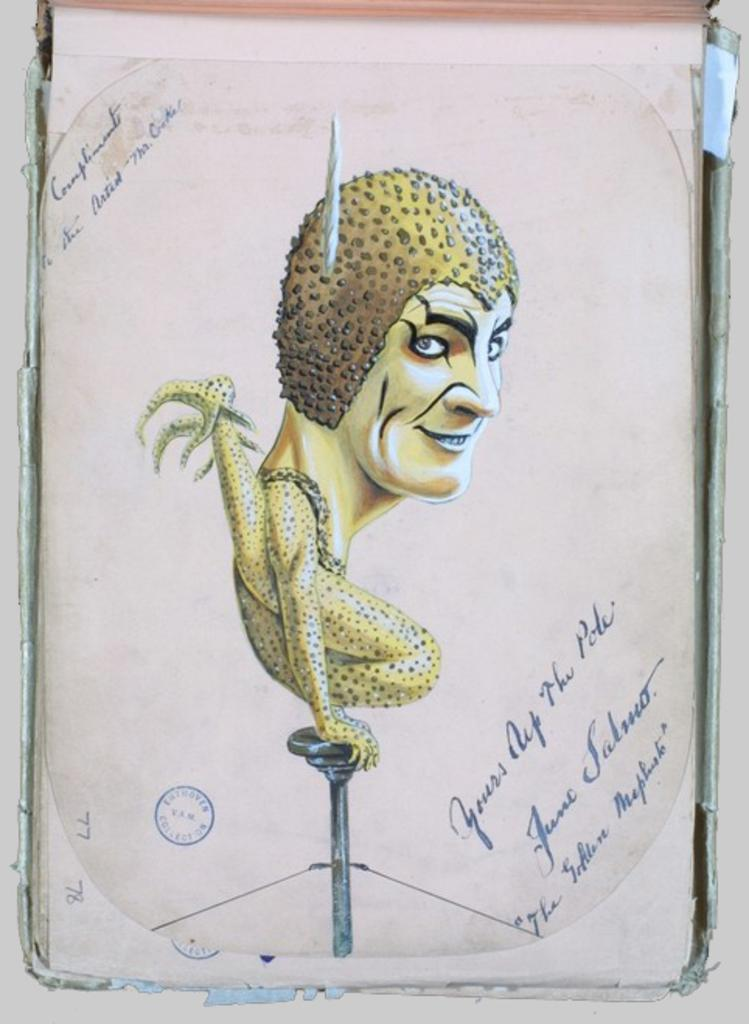What is the main object in the picture? There is a card in the picture. What can be seen on the card? The card has a cartoon image on it. Are there any words or numbers on the card? Yes, there is some information on the card. What else is visible near the card? There is a stamp near the card. Can you hear the song being sung by the pig near the lake in the image? There is no pig or lake present in the image, and therefore no song can be heard. 